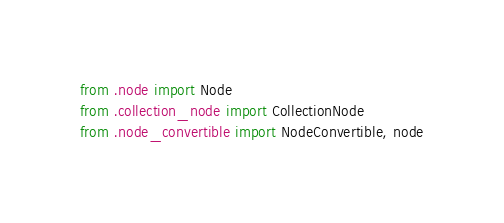<code> <loc_0><loc_0><loc_500><loc_500><_Python_>from .node import Node
from .collection_node import CollectionNode
from .node_convertible import NodeConvertible, node
</code> 